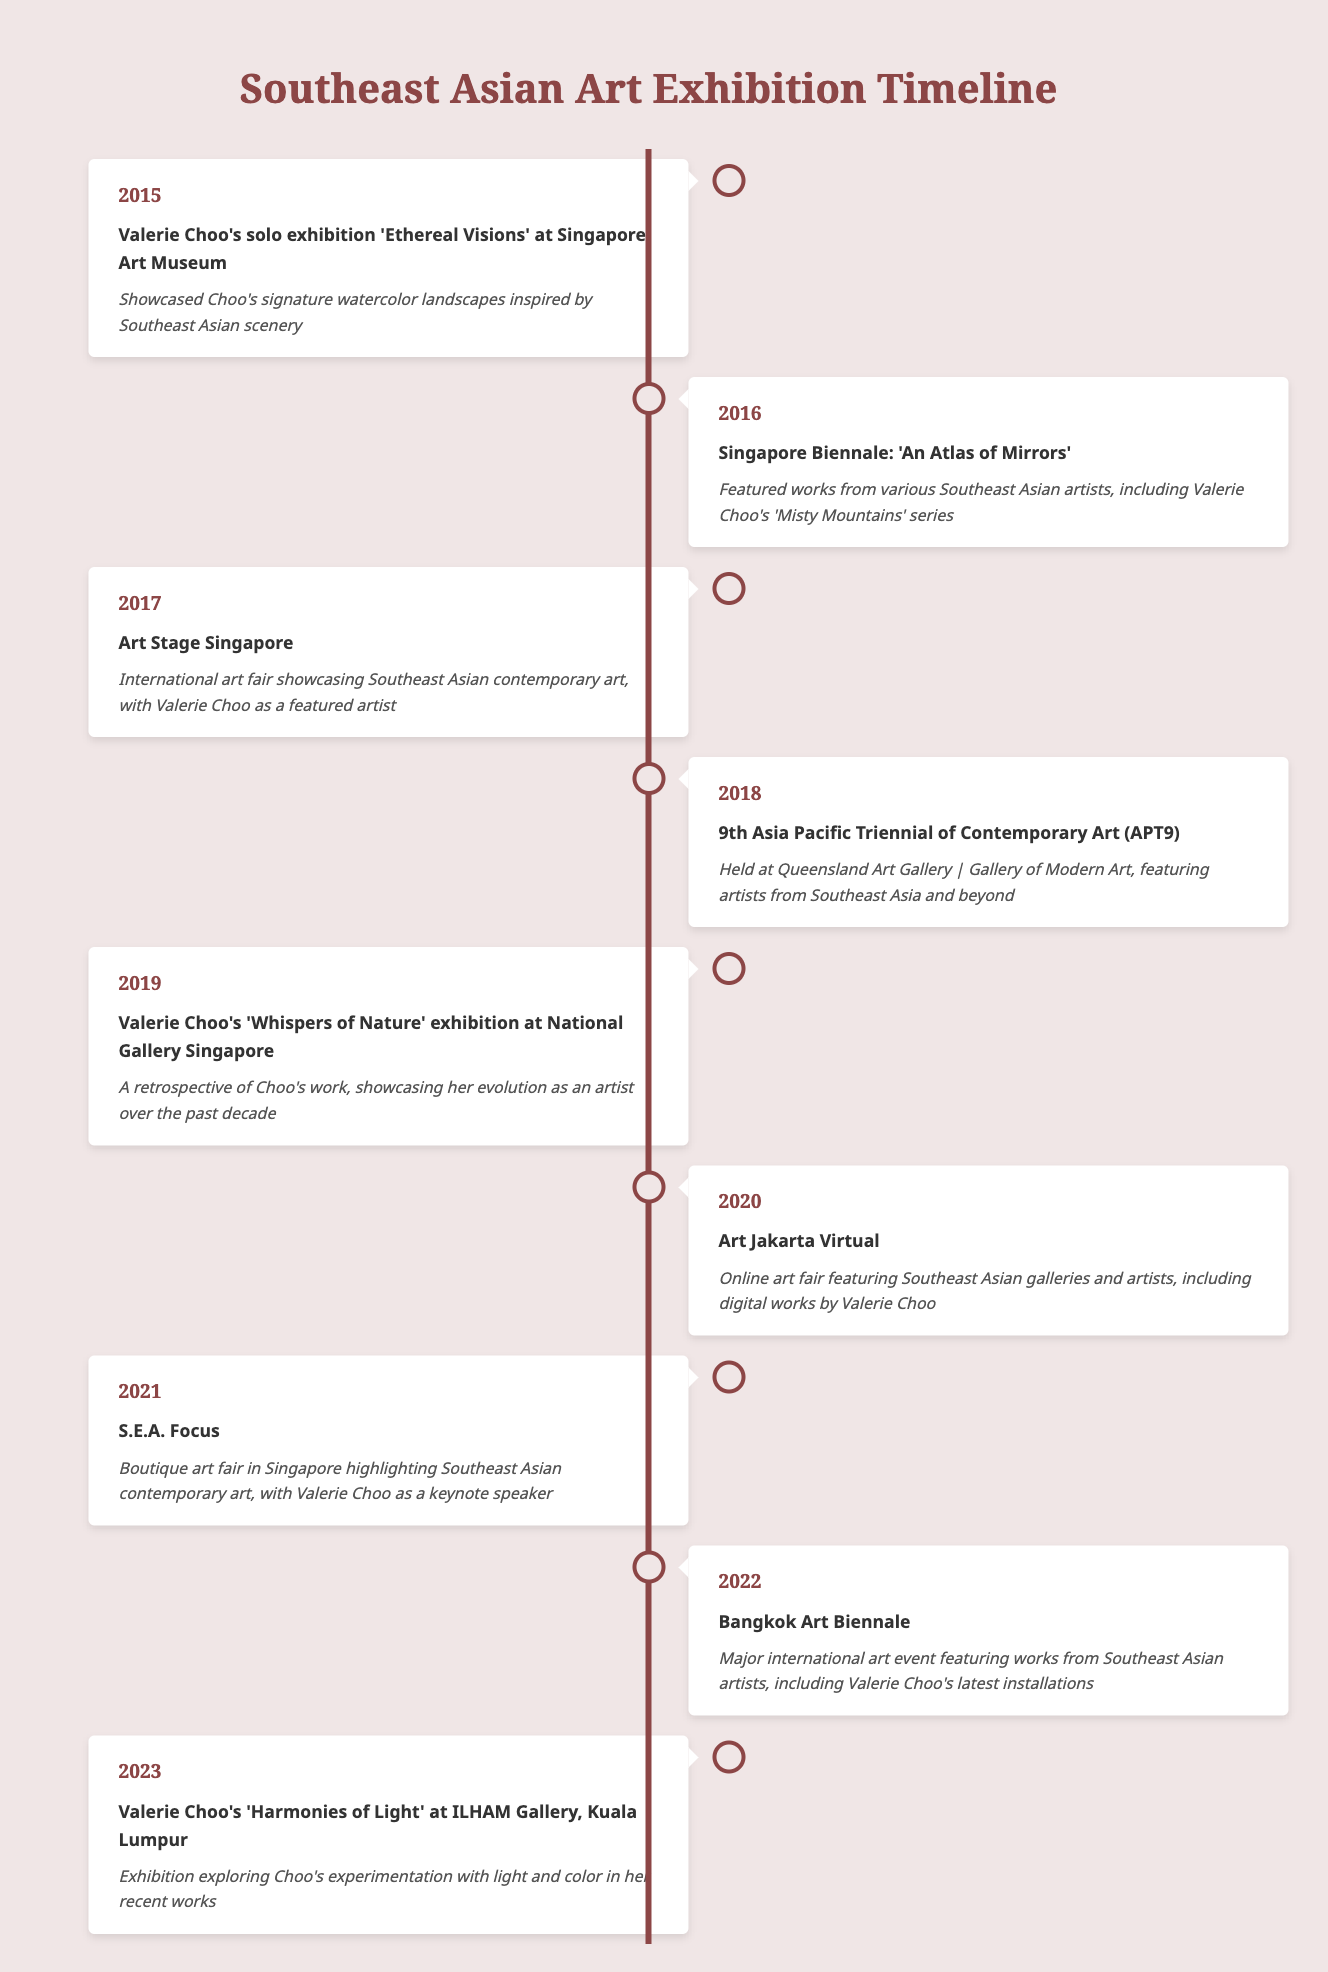What year did Valerie Choo hold her solo exhibition 'Ethereal Visions'? The table shows that Valerie Choo's solo exhibition 'Ethereal Visions' took place in 2015.
Answer: 2015 Which major art event in 2018 featured artists from Southeast Asia? According to the table, the 9th Asia Pacific Triennial of Contemporary Art (APT9) in 2018 featured artists from Southeast Asia and beyond.
Answer: 9th Asia Pacific Triennial of Contemporary Art (APT9) Was Valerie Choo featured in the Singapore Biennale in 2016? The table indicates that Valerie Choo's artwork 'Misty Mountains' series was included in the Singapore Biennale in 2016, confirming her participation.
Answer: Yes List the events from 2019 onwards. From the table, the events from 2019 onwards include: 'Whispers of Nature' exhibition in 2019, Art Jakarta Virtual in 2020, S.E.A. Focus in 2021, Bangkok Art Biennale in 2022, and 'Harmonies of Light' exhibition in 2023.
Answer: 'Whispers of Nature', 'Art Jakarta Virtual', 'S.E.A. Focus', 'Bangkok Art Biennale', 'Harmonies of Light' What is the difference in years between Valerie Choo's solo exhibition in 2015 and her latest exhibition in 2023? To find the difference, subtract the two years: 2023 - 2015 = 8 years. This shows that there is an 8-year gap between the two exhibitions.
Answer: 8 years How many exhibitions featuring Valerie Choo occurred between 2015 and 2022? By reviewing the table, we see that Valerie Choo is featured in the following exhibitions: 'Ethereal Visions' (2015), 'Misty Mountains' series in the Singapore Biennale (2016), Art Stage Singapore (2017), 'Whispers of Nature' (2019), and latest installations at Bangkok Art Biennale (2022). This totals to 5 exhibitions.
Answer: 5 exhibitions Was the Art Jakarta Virtual in 2020 an in-person event? The table describes Art Jakarta Virtual in 2020 as an online art fair, indicating that it did not take place in person.
Answer: No What was the main focus of Valerie Choo's exhibition 'Harmonies of Light'? The table notes that 'Harmonies of Light' at ILHAM Gallery in 2023 explored Choo's experimentation with light and color, defining the focus of the exhibition.
Answer: Experimentation with light and color 